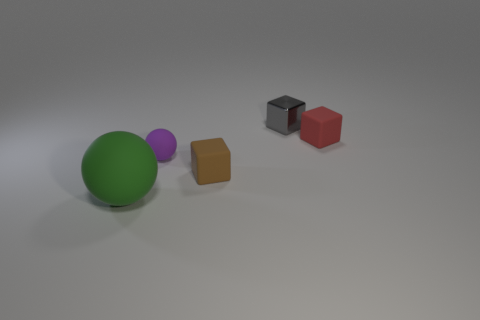Add 4 matte balls. How many objects exist? 9 Subtract all balls. How many objects are left? 3 Add 3 rubber blocks. How many rubber blocks exist? 5 Subtract 1 gray cubes. How many objects are left? 4 Subtract all small gray metal things. Subtract all tiny objects. How many objects are left? 0 Add 2 metal things. How many metal things are left? 3 